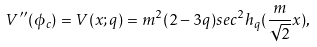<formula> <loc_0><loc_0><loc_500><loc_500>V ^ { \prime \prime } ( \phi _ { c } ) = V ( x ; q ) = m ^ { 2 } ( 2 - 3 q ) s e c ^ { 2 } h _ { q } ( \frac { m } { \sqrt { 2 } } x ) ,</formula> 